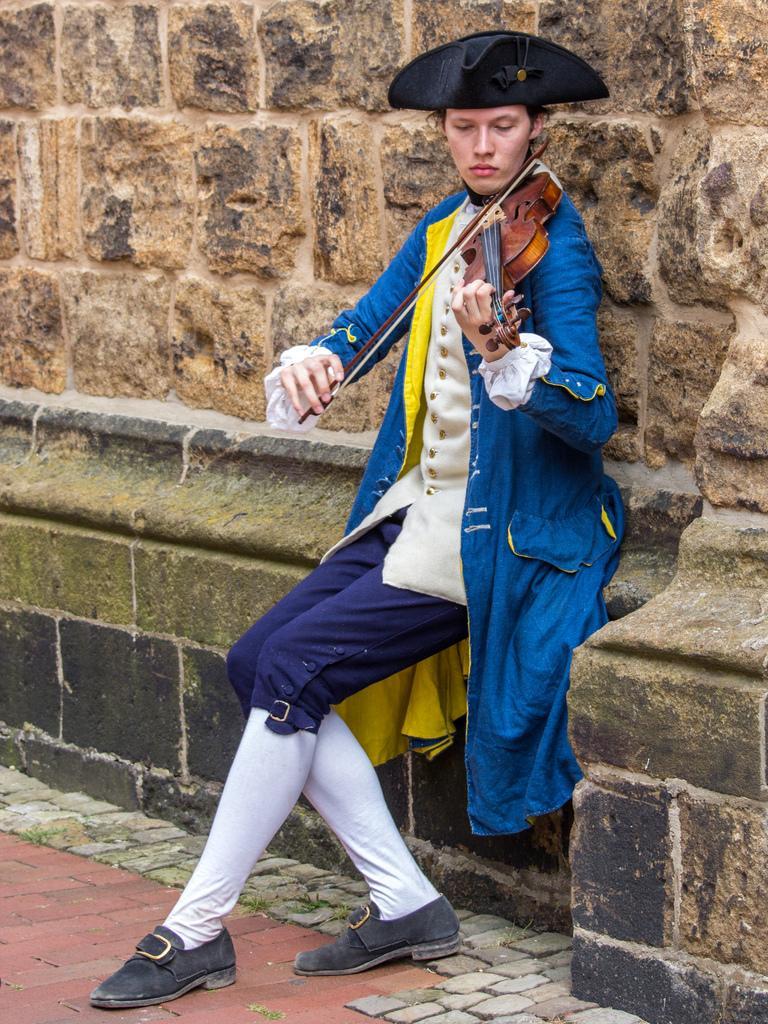In one or two sentences, can you explain what this image depicts? This image is taken outdoors. At the bottom of the image there is a floor. In the background there is a wall. In the middle of the image a man is sitting on the wall and playing music with a violin. 